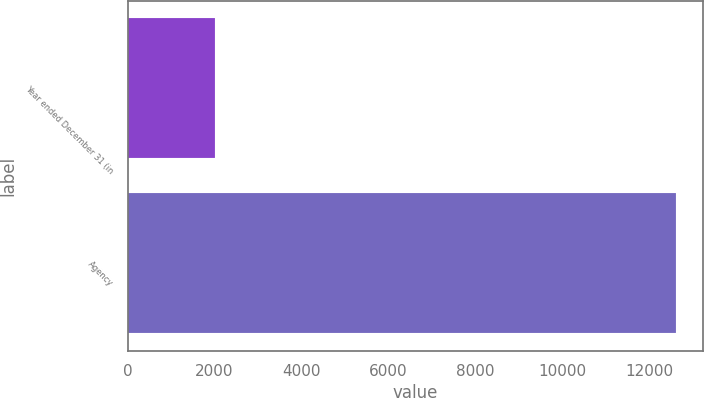<chart> <loc_0><loc_0><loc_500><loc_500><bar_chart><fcel>Year ended December 31 (in<fcel>Agency<nl><fcel>2017<fcel>12617<nl></chart> 